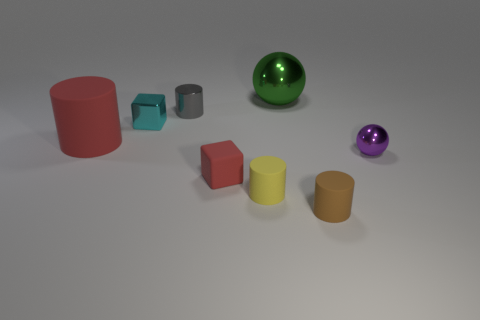Add 1 tiny brown things. How many objects exist? 9 Subtract all spheres. How many objects are left? 6 Add 7 small purple things. How many small purple things exist? 8 Subtract 0 brown cubes. How many objects are left? 8 Subtract all large blue rubber cylinders. Subtract all purple shiny things. How many objects are left? 7 Add 7 matte cylinders. How many matte cylinders are left? 10 